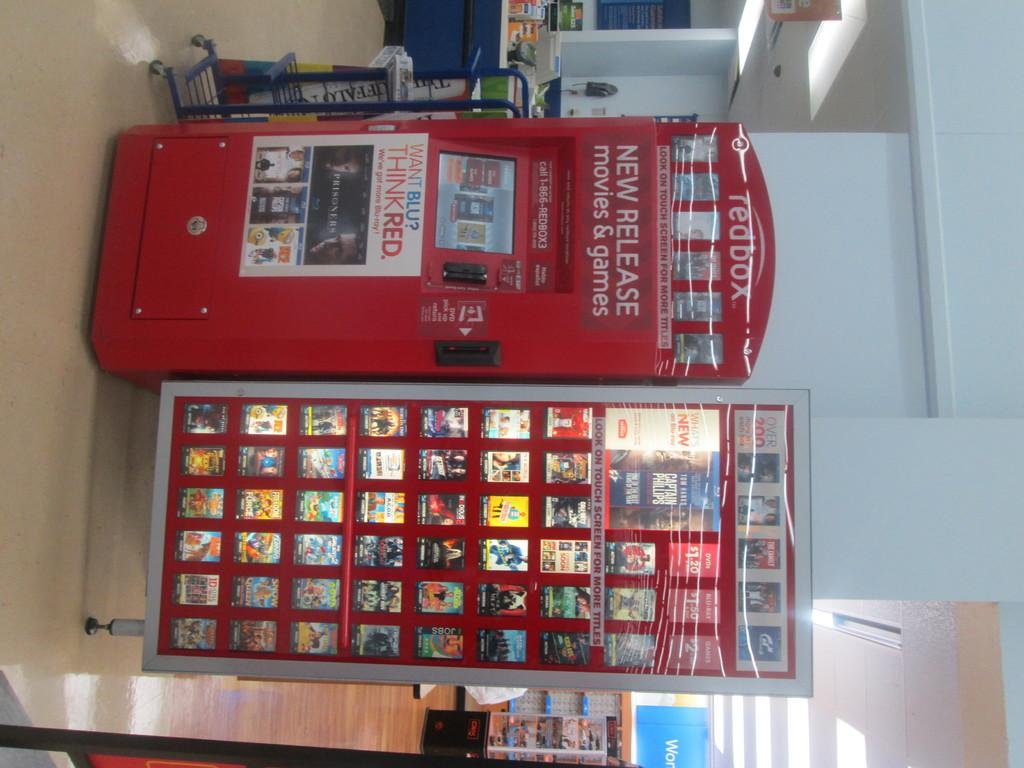What is the main object in the image? There is a machine in the image. What else can be seen in the image besides the machine? There are hoardings in the image. What is located in the background of the image? There is a countertop and lights visible in the background of the image. What type of nation is represented by the mitten in the image? There is no mitten present in the image, so it is not possible to determine what nation it might represent. 